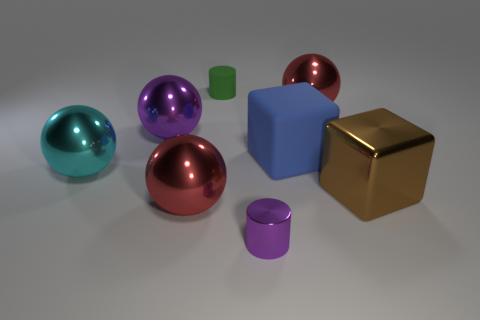How many things are either small shiny cylinders that are in front of the brown block or purple cylinders in front of the small green object?
Give a very brief answer. 1. What shape is the small purple object that is made of the same material as the big cyan sphere?
Offer a terse response. Cylinder. How many large brown rubber balls are there?
Your response must be concise. 0. How many things are things to the left of the shiny cylinder or purple cylinders?
Keep it short and to the point. 5. What number of other objects are there of the same color as the small shiny object?
Make the answer very short. 1. How many small objects are either matte blocks or cylinders?
Offer a very short reply. 2. Is the number of big metal spheres greater than the number of objects?
Offer a very short reply. No. Do the tiny purple object and the big brown cube have the same material?
Your response must be concise. Yes. Is the number of small green matte cylinders to the right of the cyan ball greater than the number of red rubber spheres?
Provide a succinct answer. Yes. How many large cyan metal things are the same shape as the big purple metallic thing?
Your answer should be compact. 1. 